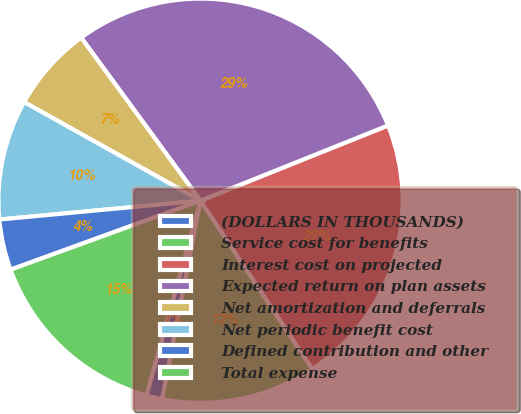<chart> <loc_0><loc_0><loc_500><loc_500><pie_chart><fcel>(DOLLARS IN THOUSANDS)<fcel>Service cost for benefits<fcel>Interest cost on projected<fcel>Expected return on plan assets<fcel>Net amortization and deferrals<fcel>Net periodic benefit cost<fcel>Defined contribution and other<fcel>Total expense<nl><fcel>1.28%<fcel>12.37%<fcel>21.74%<fcel>28.99%<fcel>6.83%<fcel>9.6%<fcel>4.06%<fcel>15.14%<nl></chart> 